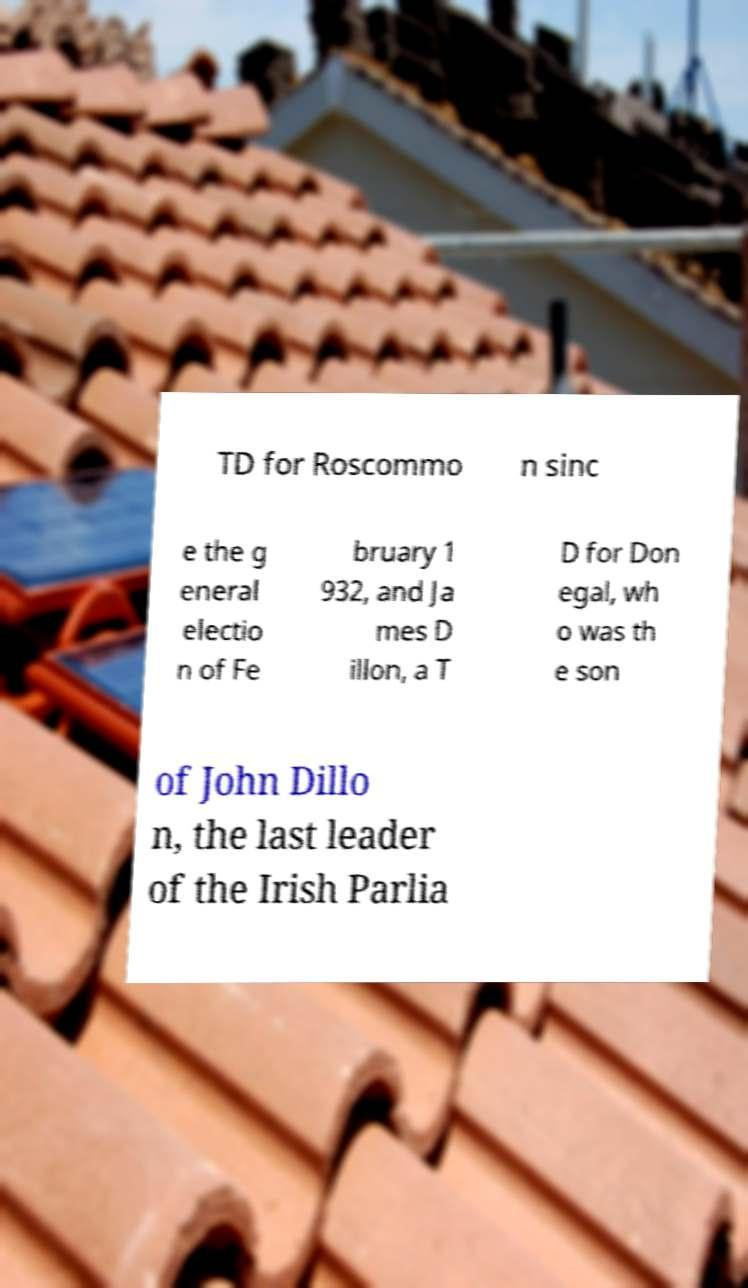What messages or text are displayed in this image? I need them in a readable, typed format. TD for Roscommo n sinc e the g eneral electio n of Fe bruary 1 932, and Ja mes D illon, a T D for Don egal, wh o was th e son of John Dillo n, the last leader of the Irish Parlia 